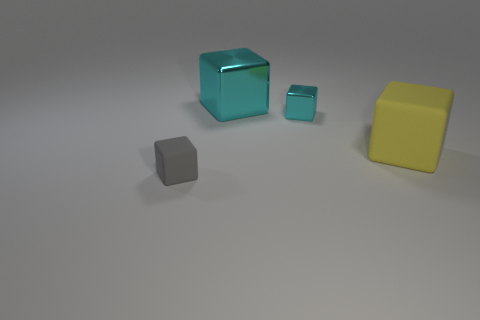Add 2 yellow shiny cylinders. How many objects exist? 6 Subtract all brown cubes. Subtract all purple cylinders. How many cubes are left? 4 Add 2 tiny cyan metallic blocks. How many tiny cyan metallic blocks are left? 3 Add 4 metal cubes. How many metal cubes exist? 6 Subtract 0 purple balls. How many objects are left? 4 Subtract all small brown rubber cylinders. Subtract all large rubber cubes. How many objects are left? 3 